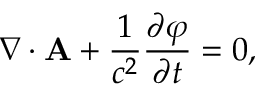<formula> <loc_0><loc_0><loc_500><loc_500>\nabla \cdot { A } + { \frac { 1 } { c ^ { 2 } } } { \frac { \partial \varphi } { \partial t } } = 0 ,</formula> 